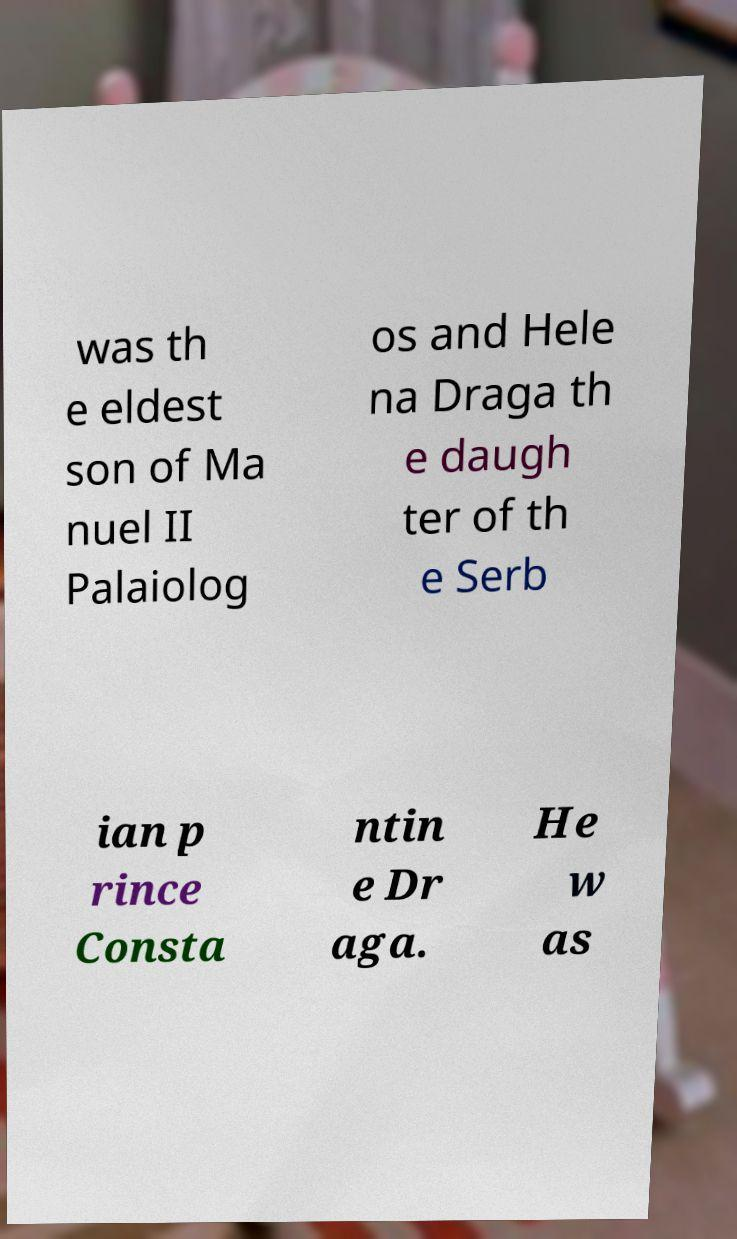I need the written content from this picture converted into text. Can you do that? was th e eldest son of Ma nuel II Palaiolog os and Hele na Draga th e daugh ter of th e Serb ian p rince Consta ntin e Dr aga. He w as 